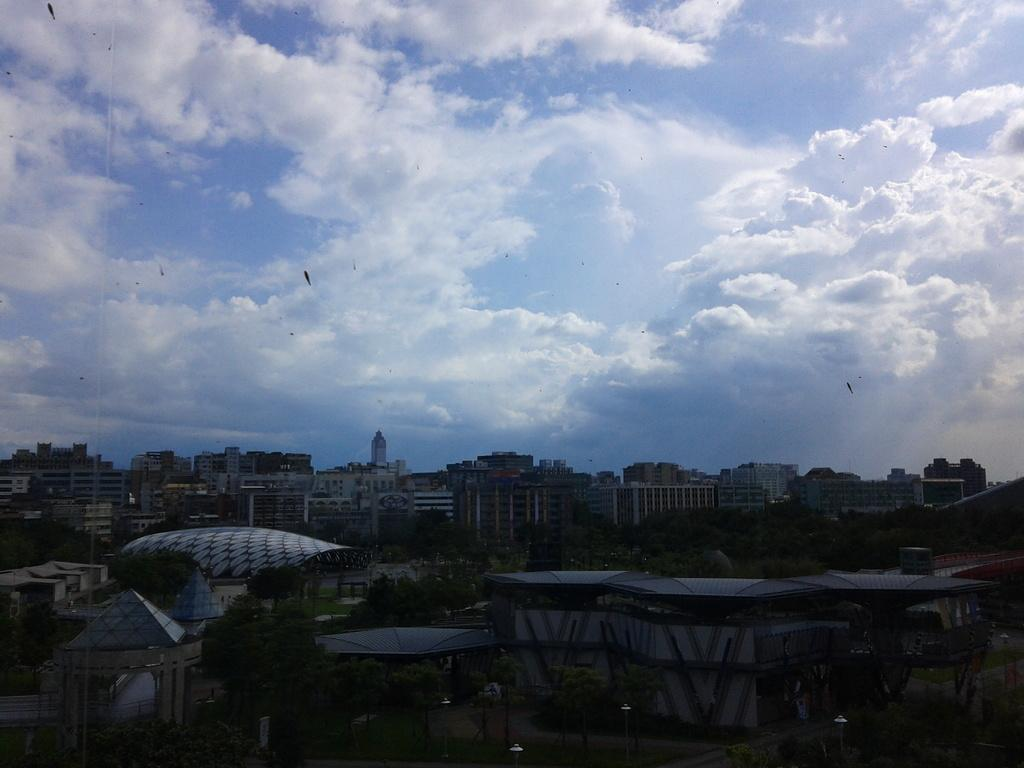What color is the sky in the image? The sky is blue at the top of the image. What structures can be seen at the bottom of the image? There are many houses and buildings visible at the bottom of the image. What type of vegetation is present in the dark area at the bottom of the image? Trees are present in the dark area at the bottom of the image. Can you see a coach in the image? There is no coach present in the image. What type of rock is visible in the image? There is no rock visible in the image. 